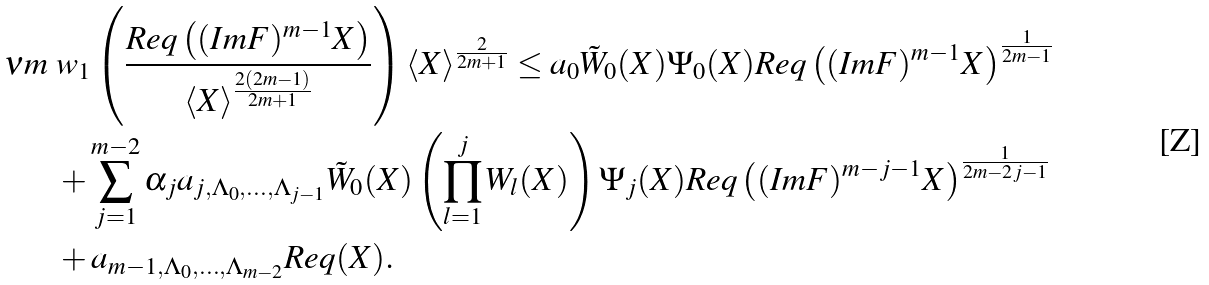Convert formula to latex. <formula><loc_0><loc_0><loc_500><loc_500>\nu m & \ w _ { 1 } \left ( \frac { R e q \left ( ( I m F ) ^ { m - 1 } X \right ) } { \langle X \rangle ^ { \frac { 2 ( 2 m - 1 ) } { 2 m + 1 } } } \right ) \langle X \rangle ^ { \frac { 2 } { 2 m + 1 } } \leq a _ { 0 } \tilde { W } _ { 0 } ( X ) \Psi _ { 0 } ( X ) R e q \left ( ( I m F ) ^ { m - 1 } X \right ) ^ { \frac { 1 } { 2 m - 1 } } \\ & \ + \sum _ { j = 1 } ^ { m - 2 } { \alpha _ { j } a _ { j , \Lambda _ { 0 } , \dots , \Lambda _ { j - 1 } } \tilde { W } _ { 0 } ( X ) \left ( \prod _ { l = 1 } ^ { j } W _ { l } ( X ) \right ) \Psi _ { j } ( X ) } R e q \left ( ( I m F ) ^ { m - j - 1 } X \right ) ^ { \frac { 1 } { 2 m - 2 j - 1 } } \\ & \ + a _ { m - 1 , \Lambda _ { 0 } , \dots , \Lambda _ { m - 2 } } R e q ( X ) .</formula> 